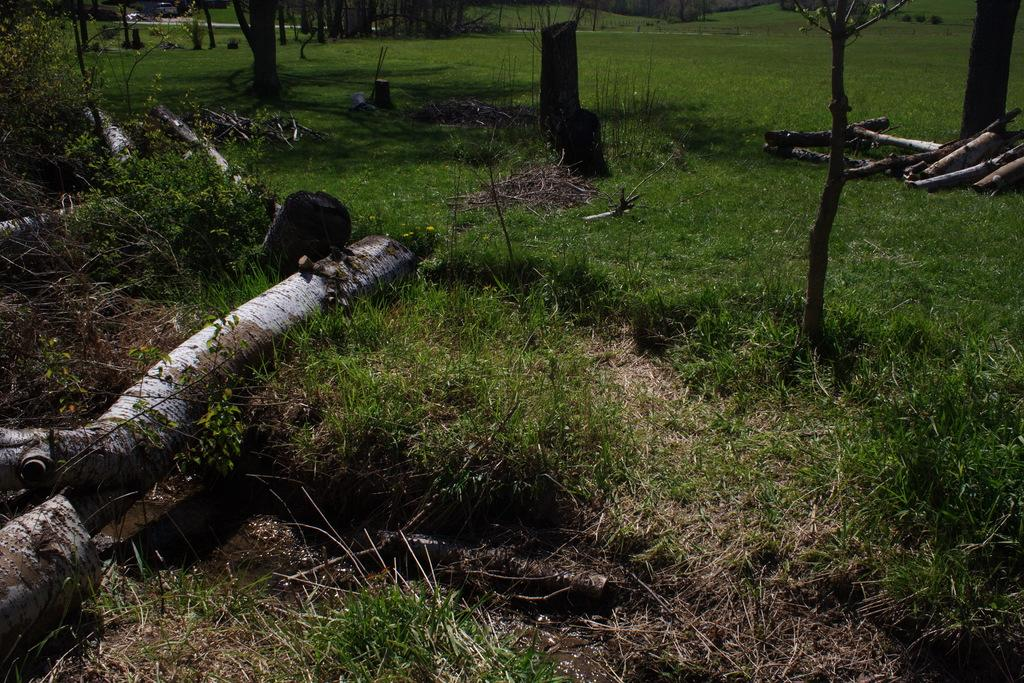What type of vegetation can be seen in the image? There is grass, plants, and trees in the image. Can you describe the natural environment depicted in the image? The natural environment includes grass, plants, and trees. Where is the grape vine located in the image? There is no grape vine present in the image. What type of art can be seen hanging from the trees in the image? There is no art present in the image; it only features grass, plants, and trees. What type of shelf can be seen holding the plants in the image? There is no shelf present in the image; the plants are not shown as being held by a shelf. 